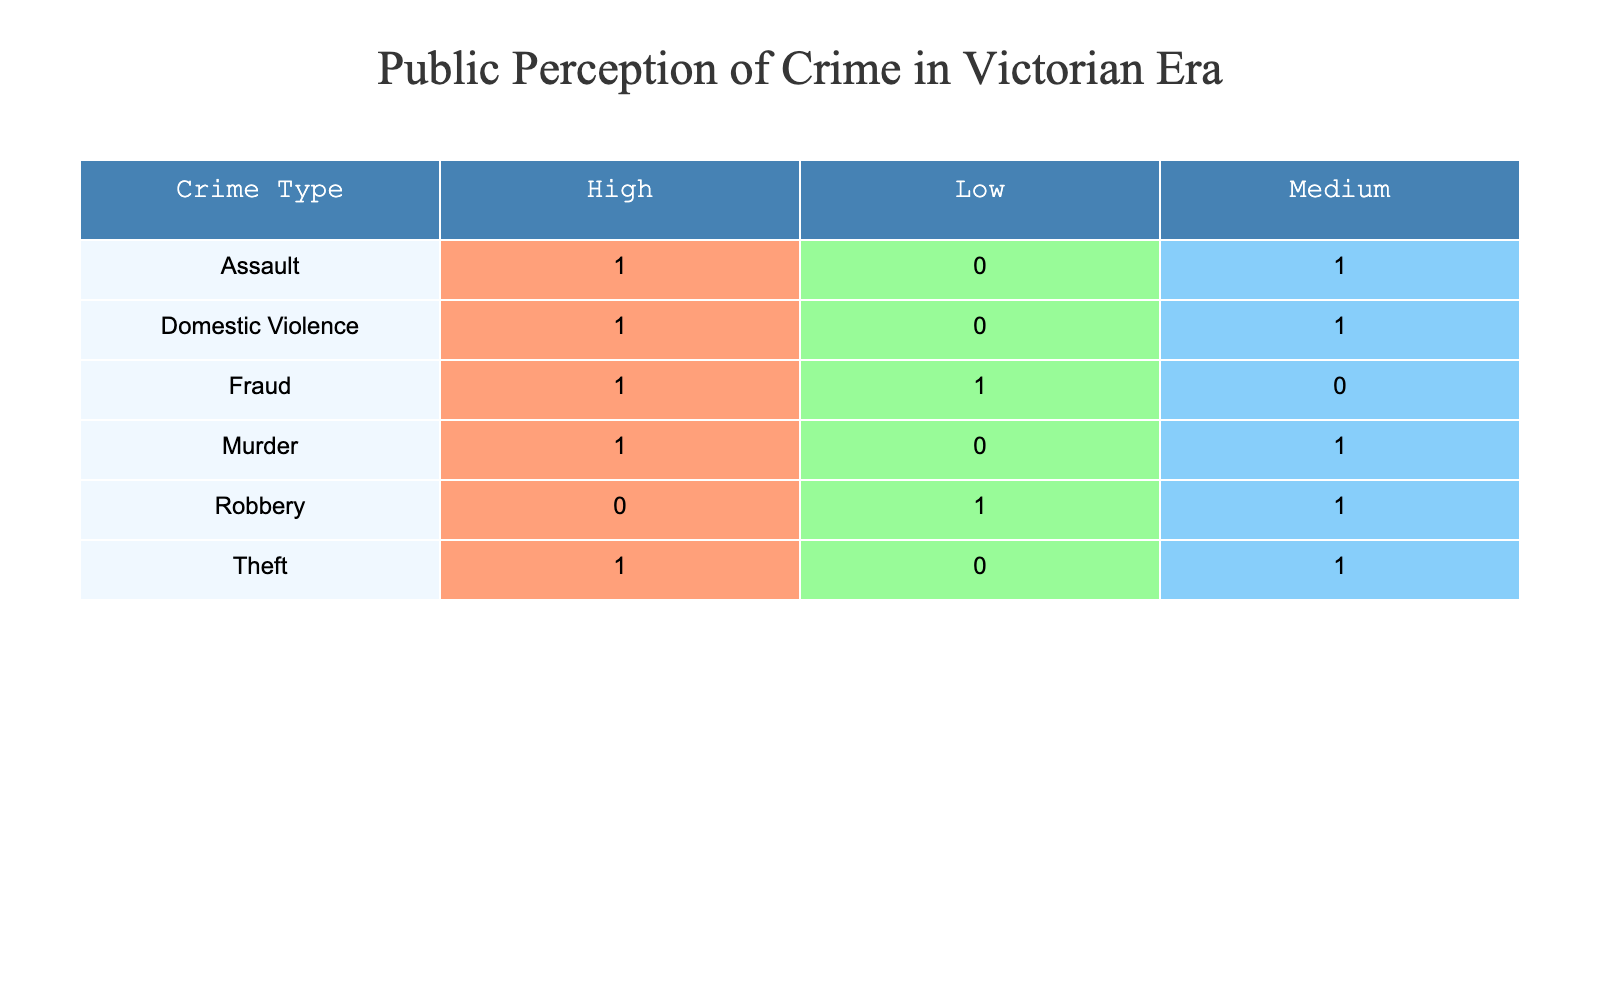What is the public perception of murder in the Victorian era? Referring to the "Crime Type" row for "Murder," I see that there are two mentions: one with a high perception and the other with a medium perception. Therefore, the perception varies.
Answer: High, Medium How many crime types have a low public perception? From the table, we can count the crime types listed under the “Low” public perception column. There are two crime types: Fraud and Robbery.
Answer: 2 Which crime type received the highest public perception rating? Looking at the “Public Perception” column, the crime types with a high rating include Murder, Assault, Theft, Domestic Violence, and Fraud. Thus, the highest counts of "High" perception comes from multiple types, but not distinctly one out of the list.
Answer: Murder, Assault, Theft, Domestic Violence Is there any crime type that has a consistent medium public perception? Examining the medium perception ratings, “Theft,” and “Domestic Violence” show up with medium reputation, but both do not have a complete uniformity across their entries. It seems they fluctuate.
Answer: No What is the total number of crimes reported in the table and how many of those received a high public perception? Adding the total number of entries in the table shows there are 10 crime entries. Crime types that received a high perception are Murder, Assault, Theft, and Domestic Violence. The high count is 4.
Answer: Total: 10, High: 4 Which newspaper reported the most crime types with high public perception? Looking through the table, "Pall Mall Gazette" reported "Theft," and "The Sun" reported "Domestic Violence," both with high perception, but “The Illustrated Police News” and “The Manchester Guardian” also reported one each. Hence, it's shared.
Answer: Shared Did fraud receive high public perception in more than one instance? The table shows Fraud only appears once, and its perception is categorized as low in the instance provided. Thus, it did not receive high perception.
Answer: No How does the perception of domestic violence compare to theft in the Victorian era? Analyzing the table, domestic violence received a high perception while theft has both high and medium perception. This indicates there’s a disparity where domestic violence might be viewed more severely.
Answer: Domestic violence is higher than theft 